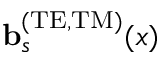<formula> <loc_0><loc_0><loc_500><loc_500>{ b } _ { s } ^ { ( T E , T M ) } ( x )</formula> 